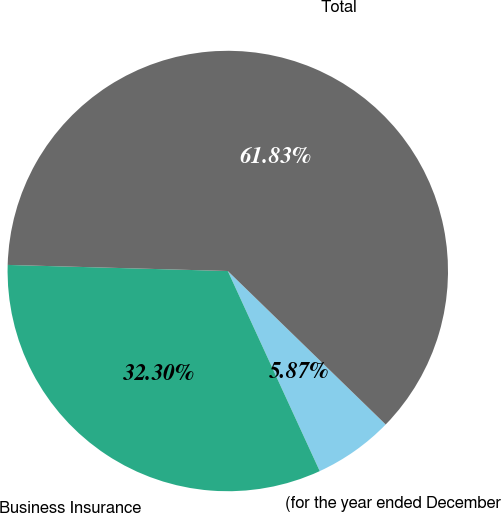Convert chart. <chart><loc_0><loc_0><loc_500><loc_500><pie_chart><fcel>(for the year ended December<fcel>Business Insurance<fcel>Total<nl><fcel>5.87%<fcel>32.3%<fcel>61.84%<nl></chart> 